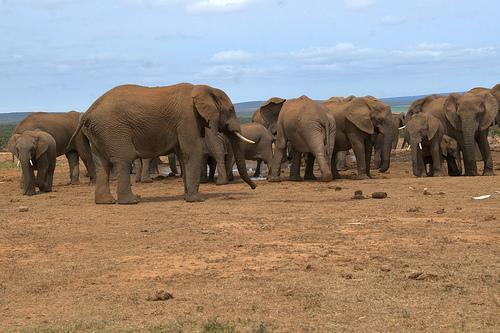How many ears do elephants have?
Give a very brief answer. 2. How many elephants are standing on two legs?
Give a very brief answer. 0. 